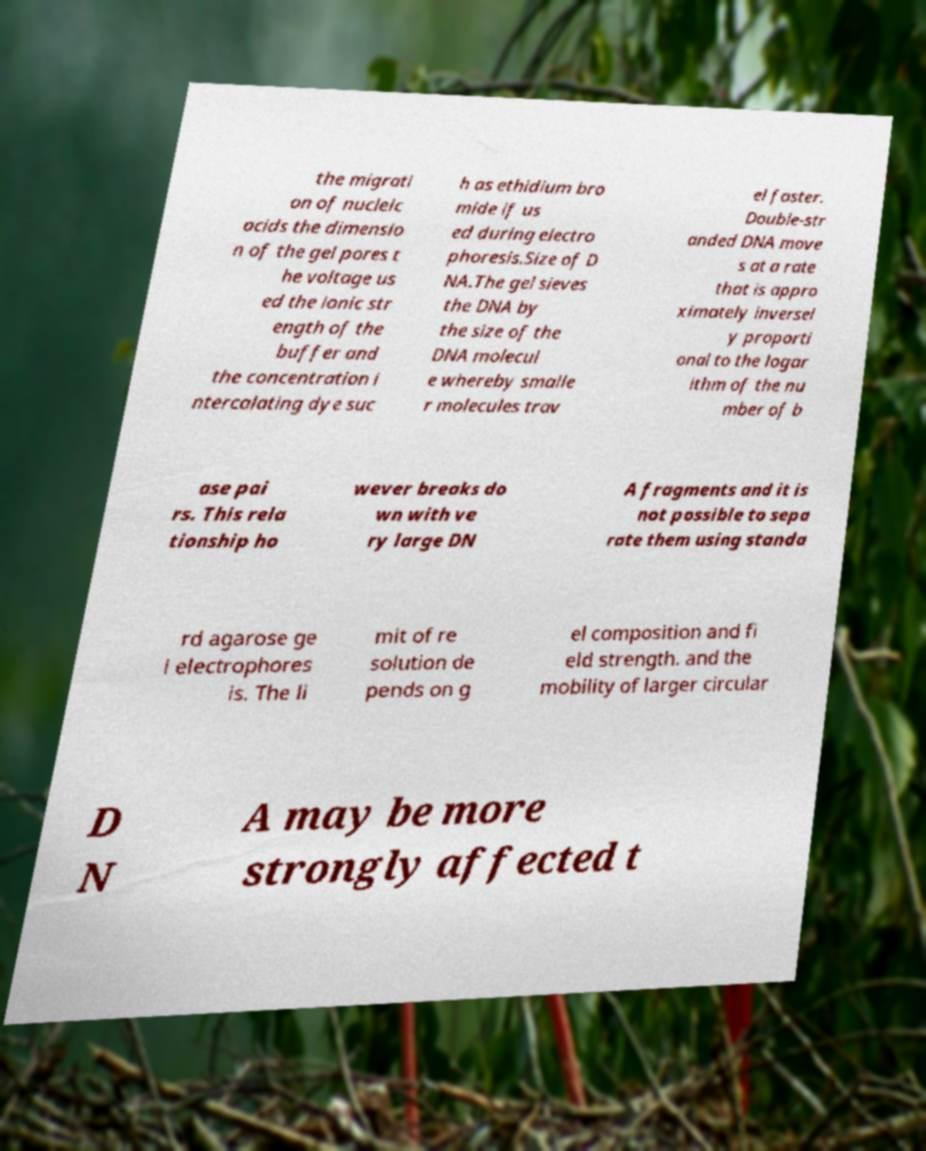Can you accurately transcribe the text from the provided image for me? the migrati on of nucleic acids the dimensio n of the gel pores t he voltage us ed the ionic str ength of the buffer and the concentration i ntercalating dye suc h as ethidium bro mide if us ed during electro phoresis.Size of D NA.The gel sieves the DNA by the size of the DNA molecul e whereby smalle r molecules trav el faster. Double-str anded DNA move s at a rate that is appro ximately inversel y proporti onal to the logar ithm of the nu mber of b ase pai rs. This rela tionship ho wever breaks do wn with ve ry large DN A fragments and it is not possible to sepa rate them using standa rd agarose ge l electrophores is. The li mit of re solution de pends on g el composition and fi eld strength. and the mobility of larger circular D N A may be more strongly affected t 